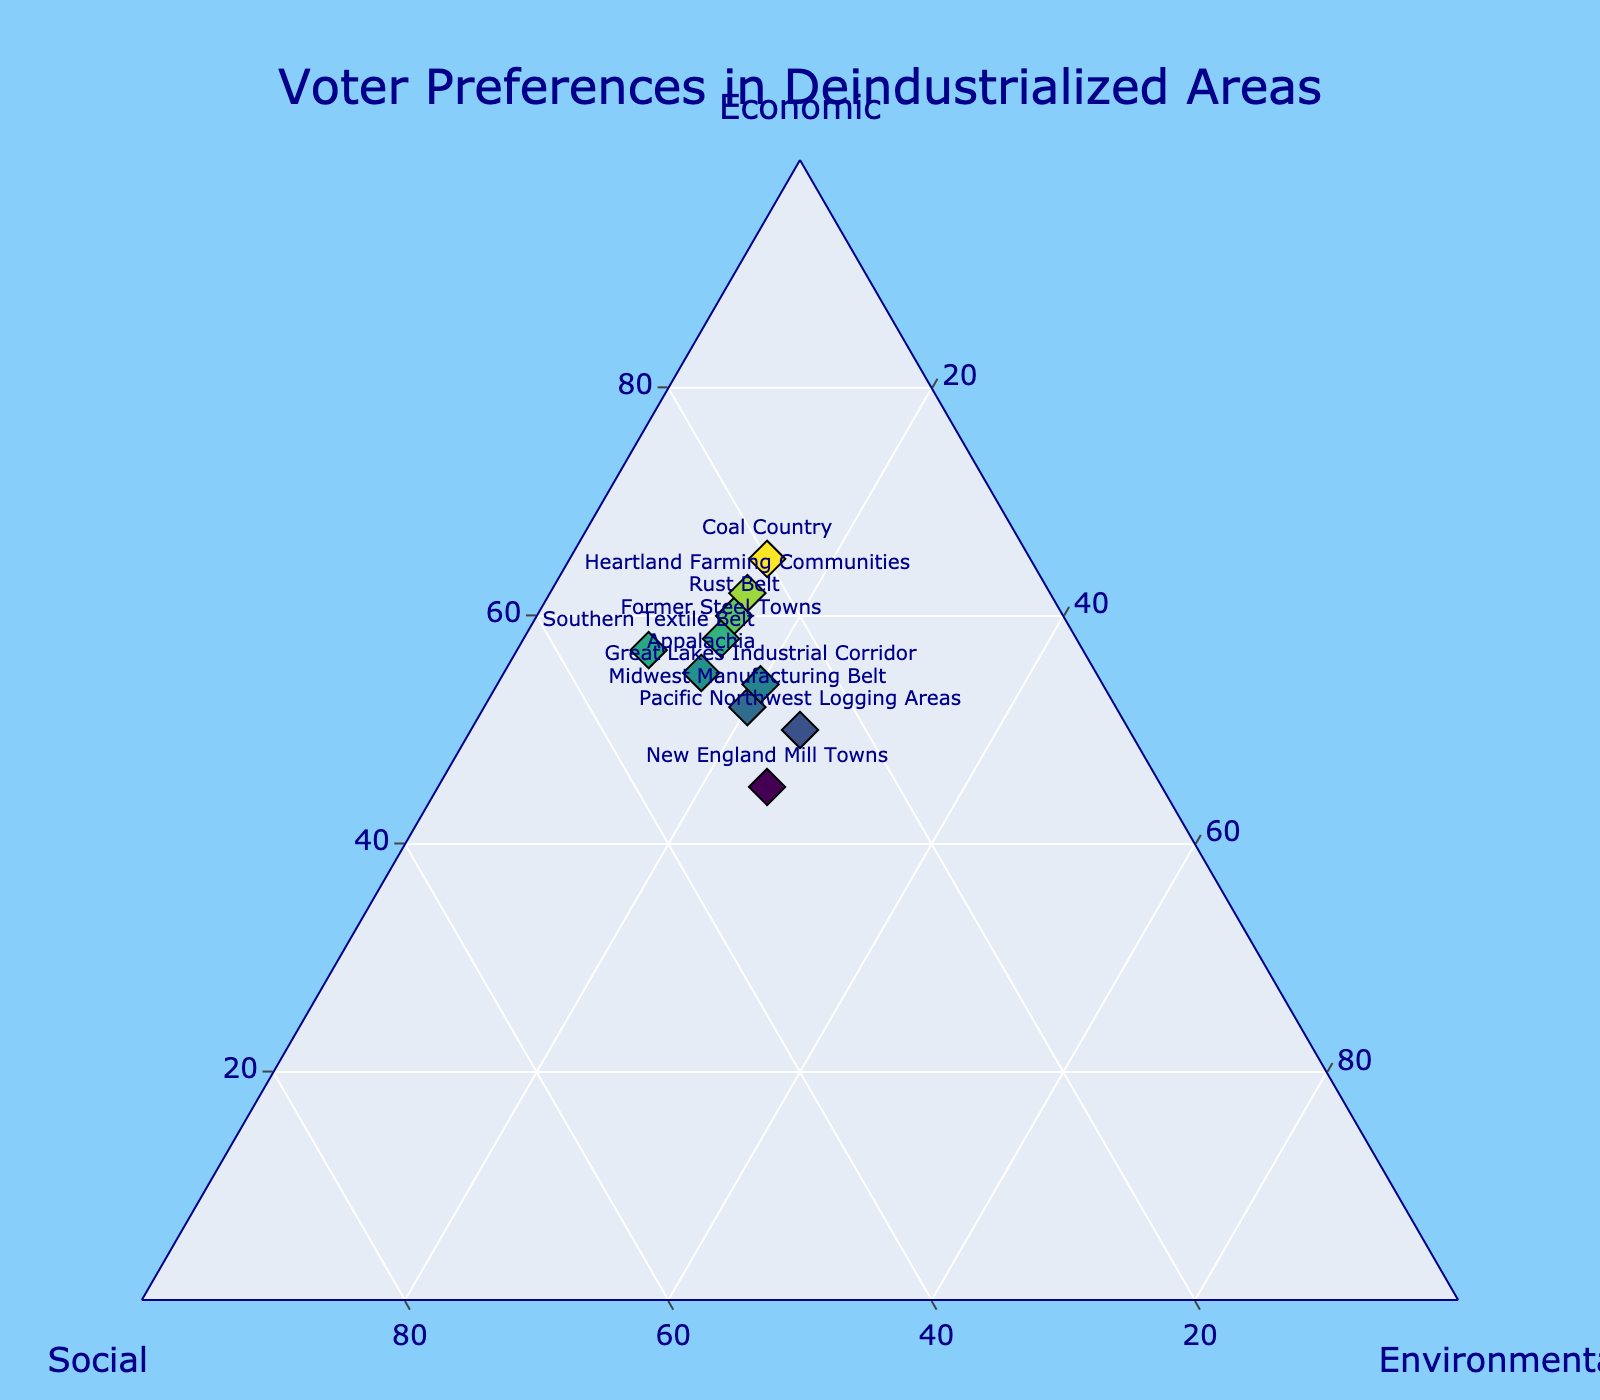What's the title of the plot? The title is the primary text displayed at the top of the figure, usually explaining the theme or main subject of the plot. In this case, it reads 'Voter Preferences in Deindustrialized Areas'.
Answer: Voter Preferences in Deindustrialized Areas Which region has the highest preference for economic policies? By looking at the points and their labels, the region with the highest value on the Economic axis will have the most significant emphasis on economic policies. Here, 'Coal Country' has the highest percentage at 65%.
Answer: Coal Country What are the preferences for 'Pacific Northwest Logging Areas'? Locate 'Pacific Northwest Logging Areas' in the plot and read the associated values for Economic, Social, and Environmental axes. The plot shows that the values are approximately 50%, 25%, and 25% respectively.
Answer: Economic: 50%, Social: 25%, Environmental: 25% Which region prioritizes environmental concerns the most? The region with the highest percentage on the Environmental axis can be identified easily by its label. 'New England Mill Towns' shows the highest environmental preference at 25%.
Answer: New England Mill Towns Are there any regions with equal preference for social and environmental issues? Scan the plot for data points where the Social and Environmental axes have the same values. 'New England Mill Towns' and 'Pacific Northwest Logging Areas' both show 30% for Social and 25% for Environmental.
Answer: New England Mill Towns, Pacific Northwest Logging Areas Compare economic preferences between 'Rust Belt' and 'Southern Textile Belt'. Which is higher and by how much? Identify the economic values for both regions (60% for Rust Belt and 57% for Southern Textile Belt). Subtract the smaller value from the larger one to find the difference.
Answer: Rust Belt is higher by 3% What is the average environmental preference across all regions? Add all the environmental percentages together (15 + 15 + 15 + 15 + 20 + 25 + 25 + 10 + 20 + 15) and divide by the number of regions (10).
Answer: 17.5% Which region has the most balanced proportions across all three preferences? Look for the point closest to the centroid (33.33%, 33.33%, 33.33%) of the ternary plot. 'New England Mill Towns' is the closest with 45% Economic, 30% Social, and 25% Environmental.
Answer: New England Mill Towns Are there any regions whose social preferences exceed 30%? Scan the Social axis for values greater than 30% and identify their labels. 'Southern Textile Belt' has a social preference of 33%.
Answer: Southern Textile Belt 